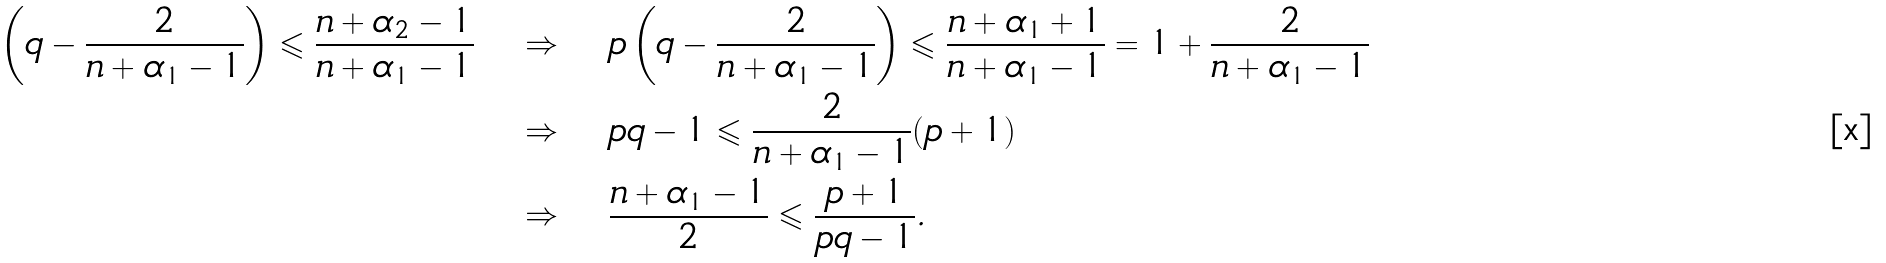Convert formula to latex. <formula><loc_0><loc_0><loc_500><loc_500>\left ( q - \frac { 2 } { n + \alpha _ { 1 } - 1 } \right ) \leqslant \frac { n + \alpha _ { 2 } - 1 } { n + \alpha _ { 1 } - 1 } & \quad \Rightarrow \quad p \left ( q - \frac { 2 } { n + \alpha _ { 1 } - 1 } \right ) \leqslant \frac { n + \alpha _ { 1 } + 1 } { n + \alpha _ { 1 } - 1 } = 1 + \frac { 2 } { n + \alpha _ { 1 } - 1 } \\ & \quad \Rightarrow \quad p q - 1 \leqslant \frac { 2 } { n + \alpha _ { 1 } - 1 } ( p + 1 ) \\ & \quad \Rightarrow \quad \frac { n + \alpha _ { 1 } - 1 } { 2 } \leqslant \frac { p + 1 } { p q - 1 } .</formula> 